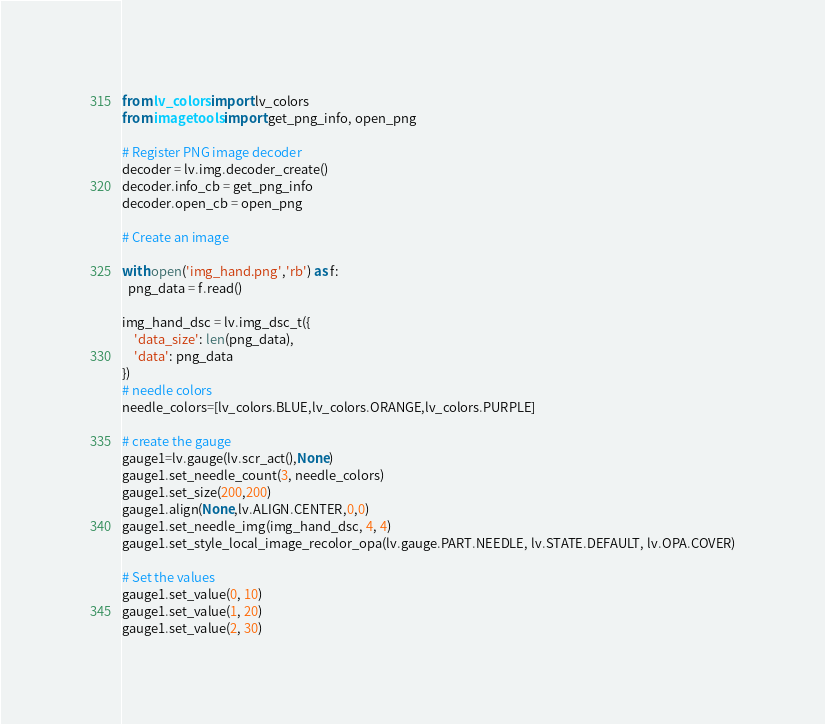<code> <loc_0><loc_0><loc_500><loc_500><_Python_>from lv_colors import lv_colors
from imagetools import get_png_info, open_png

# Register PNG image decoder
decoder = lv.img.decoder_create()
decoder.info_cb = get_png_info
decoder.open_cb = open_png

# Create an image

with open('img_hand.png','rb') as f:
  png_data = f.read()

img_hand_dsc = lv.img_dsc_t({
    'data_size': len(png_data),
    'data': png_data 
})
# needle colors
needle_colors=[lv_colors.BLUE,lv_colors.ORANGE,lv_colors.PURPLE]

# create the gauge
gauge1=lv.gauge(lv.scr_act(),None)
gauge1.set_needle_count(3, needle_colors)
gauge1.set_size(200,200)
gauge1.align(None,lv.ALIGN.CENTER,0,0)
gauge1.set_needle_img(img_hand_dsc, 4, 4)
gauge1.set_style_local_image_recolor_opa(lv.gauge.PART.NEEDLE, lv.STATE.DEFAULT, lv.OPA.COVER)

# Set the values
gauge1.set_value(0, 10)
gauge1.set_value(1, 20)
gauge1.set_value(2, 30)

</code> 